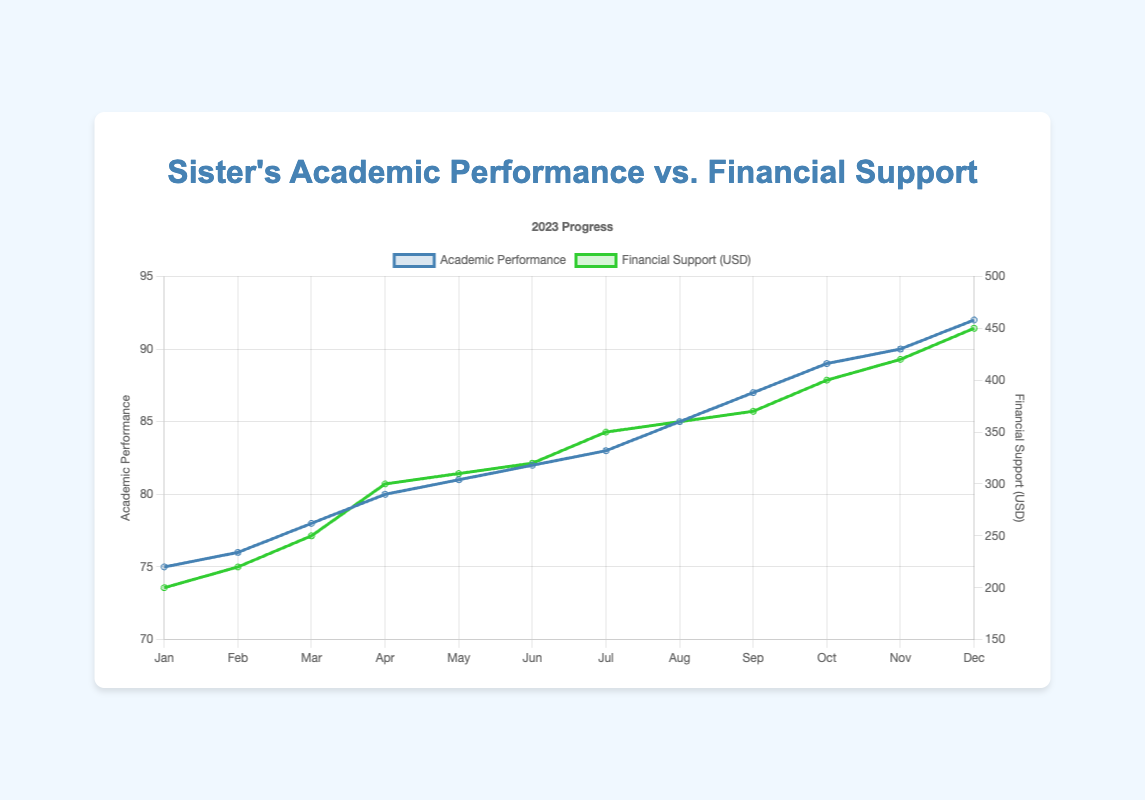Which month saw the highest academic performance? The highest academic performance is represented by the peak of the blue line on the graph, which occurs in December with a value of 92.
Answer: December What is the total financial support provided in the first quarter (Q1) of 2023? Sum the financial support amounts for January, February, and March (200 + 220 + 250 = 670).
Answer: 670 USD Did the academic performance ever decrease in the year 2023? By observing the line chart, we see that the blue line representing academic performance continuously increases without any dips throughout the year.
Answer: No How much did financial support increase from January to December? Subtract the financial support amount in January from that in December (450 - 200 = 250).
Answer: 250 USD In which month did the academic performance first reach 80? By checking the blue line chart, academic performance first hits 80 in April.
Answer: April What is the difference in financial support between March and September? Subtract the financial support amount of March from that of September (370 - 250 = 120).
Answer: 120 USD How much did the academic performance improve from June to October? Subtract the academic performance in June from that in October (89 - 82 = 7).
Answer: 7 points Are there any months where financial support remained constant? Examining the green line, financial support continually increases and never stays the same across any two consecutive months.
Answer: No Is there a clear correlation between the increase in financial support and improvement in academic performance? Both lines (green for financial support and blue for academic performance) show a consistent upward trend, indicating that as financial support increases, academic performance also improves.
Answer: Yes What is the total academic performance improvement over the whole year from January to December? Subtract the academic performance value in January from that in December (92 - 75 = 17).
Answer: 17 points 